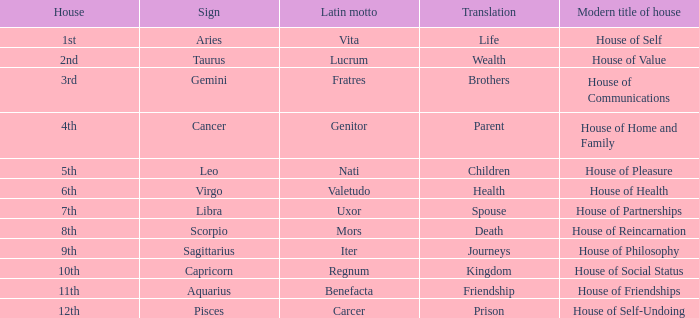What is the present-day title of the 1st house? House of Self. 